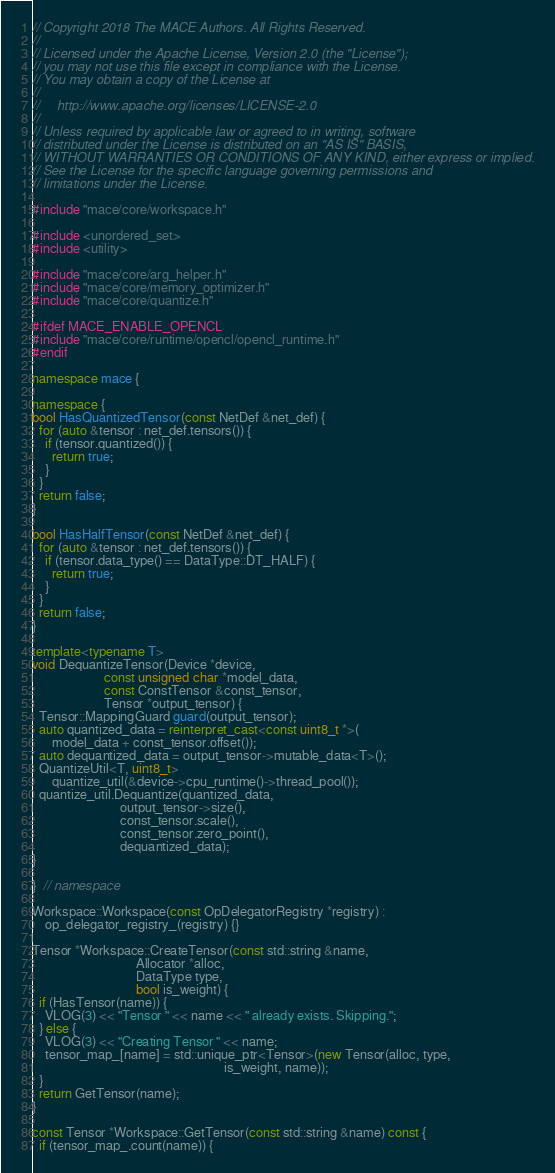<code> <loc_0><loc_0><loc_500><loc_500><_C++_>// Copyright 2018 The MACE Authors. All Rights Reserved.
//
// Licensed under the Apache License, Version 2.0 (the "License");
// you may not use this file except in compliance with the License.
// You may obtain a copy of the License at
//
//     http://www.apache.org/licenses/LICENSE-2.0
//
// Unless required by applicable law or agreed to in writing, software
// distributed under the License is distributed on an "AS IS" BASIS,
// WITHOUT WARRANTIES OR CONDITIONS OF ANY KIND, either express or implied.
// See the License for the specific language governing permissions and
// limitations under the License.

#include "mace/core/workspace.h"

#include <unordered_set>
#include <utility>

#include "mace/core/arg_helper.h"
#include "mace/core/memory_optimizer.h"
#include "mace/core/quantize.h"

#ifdef MACE_ENABLE_OPENCL
#include "mace/core/runtime/opencl/opencl_runtime.h"
#endif

namespace mace {

namespace {
bool HasQuantizedTensor(const NetDef &net_def) {
  for (auto &tensor : net_def.tensors()) {
    if (tensor.quantized()) {
      return true;
    }
  }
  return false;
}

bool HasHalfTensor(const NetDef &net_def) {
  for (auto &tensor : net_def.tensors()) {
    if (tensor.data_type() == DataType::DT_HALF) {
      return true;
    }
  }
  return false;
}

template<typename T>
void DequantizeTensor(Device *device,
                      const unsigned char *model_data,
                      const ConstTensor &const_tensor,
                      Tensor *output_tensor) {
  Tensor::MappingGuard guard(output_tensor);
  auto quantized_data = reinterpret_cast<const uint8_t *>(
      model_data + const_tensor.offset());
  auto dequantized_data = output_tensor->mutable_data<T>();
  QuantizeUtil<T, uint8_t>
      quantize_util(&device->cpu_runtime()->thread_pool());
  quantize_util.Dequantize(quantized_data,
                           output_tensor->size(),
                           const_tensor.scale(),
                           const_tensor.zero_point(),
                           dequantized_data);
}

}  // namespace

Workspace::Workspace(const OpDelegatorRegistry *registry) :
    op_delegator_registry_(registry) {}

Tensor *Workspace::CreateTensor(const std::string &name,
                                Allocator *alloc,
                                DataType type,
                                bool is_weight) {
  if (HasTensor(name)) {
    VLOG(3) << "Tensor " << name << " already exists. Skipping.";
  } else {
    VLOG(3) << "Creating Tensor " << name;
    tensor_map_[name] = std::unique_ptr<Tensor>(new Tensor(alloc, type,
                                                           is_weight, name));
  }
  return GetTensor(name);
}

const Tensor *Workspace::GetTensor(const std::string &name) const {
  if (tensor_map_.count(name)) {</code> 